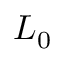Convert formula to latex. <formula><loc_0><loc_0><loc_500><loc_500>L _ { 0 }</formula> 